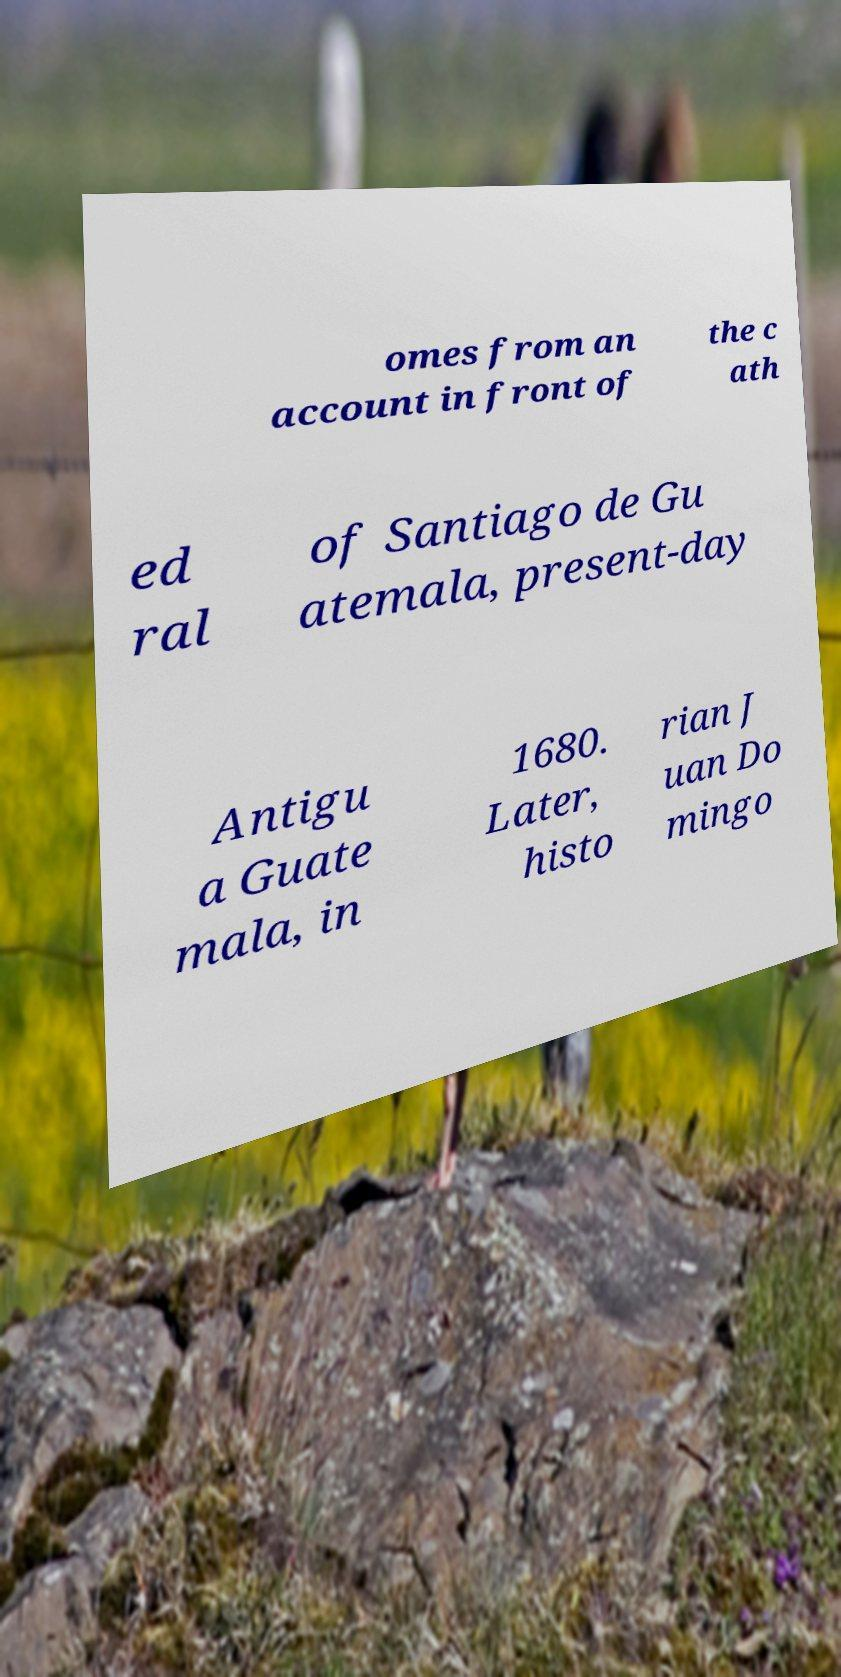Can you read and provide the text displayed in the image?This photo seems to have some interesting text. Can you extract and type it out for me? omes from an account in front of the c ath ed ral of Santiago de Gu atemala, present-day Antigu a Guate mala, in 1680. Later, histo rian J uan Do mingo 